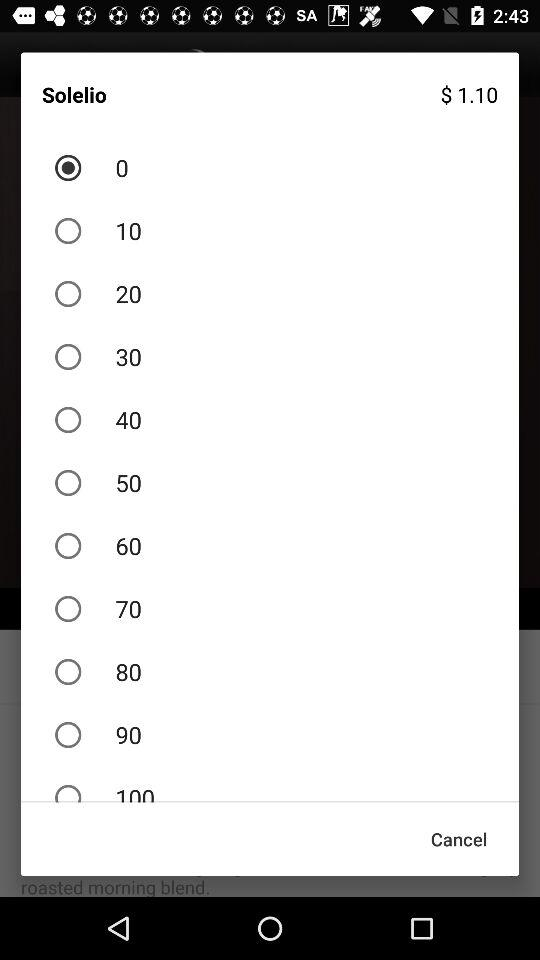Which option is selected? The selected option is 0. 